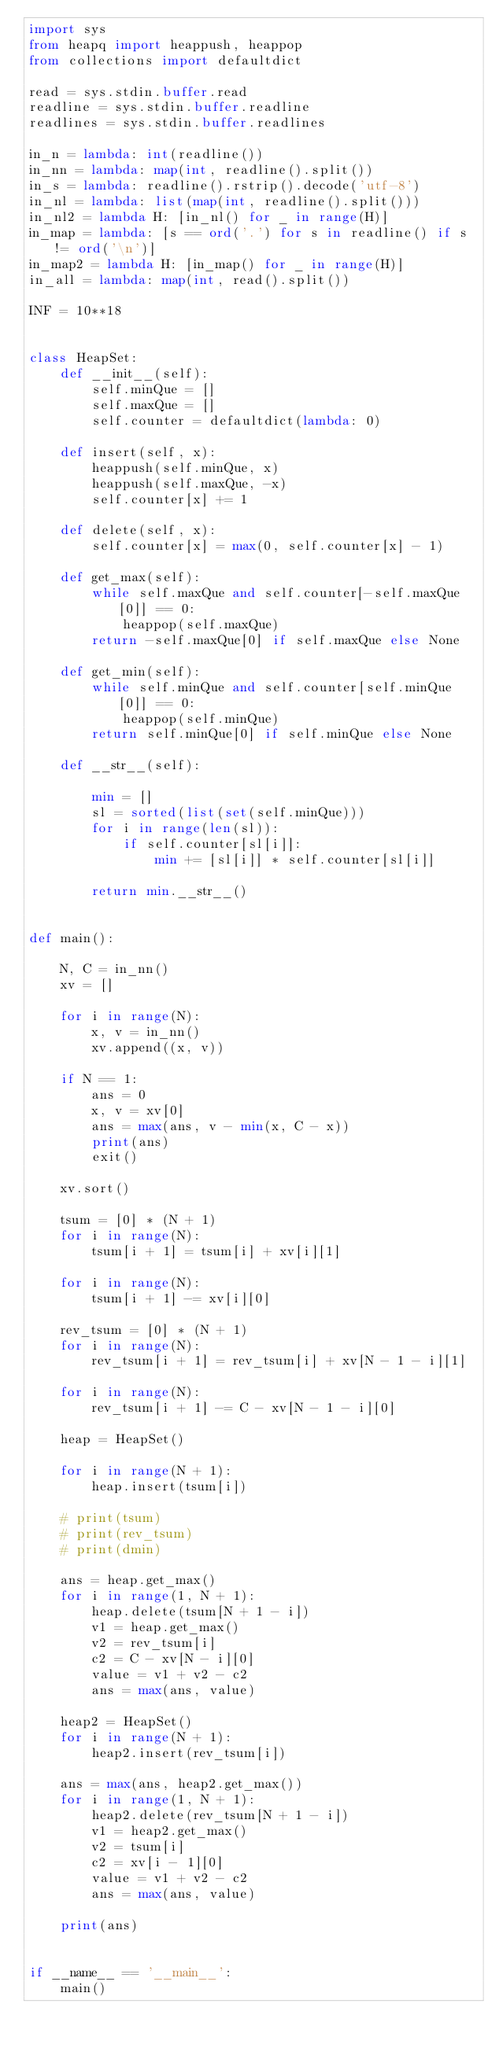<code> <loc_0><loc_0><loc_500><loc_500><_Python_>import sys
from heapq import heappush, heappop
from collections import defaultdict

read = sys.stdin.buffer.read
readline = sys.stdin.buffer.readline
readlines = sys.stdin.buffer.readlines

in_n = lambda: int(readline())
in_nn = lambda: map(int, readline().split())
in_s = lambda: readline().rstrip().decode('utf-8')
in_nl = lambda: list(map(int, readline().split()))
in_nl2 = lambda H: [in_nl() for _ in range(H)]
in_map = lambda: [s == ord('.') for s in readline() if s != ord('\n')]
in_map2 = lambda H: [in_map() for _ in range(H)]
in_all = lambda: map(int, read().split())

INF = 10**18


class HeapSet:
    def __init__(self):
        self.minQue = []
        self.maxQue = []
        self.counter = defaultdict(lambda: 0)

    def insert(self, x):
        heappush(self.minQue, x)
        heappush(self.maxQue, -x)
        self.counter[x] += 1

    def delete(self, x):
        self.counter[x] = max(0, self.counter[x] - 1)

    def get_max(self):
        while self.maxQue and self.counter[-self.maxQue[0]] == 0:
            heappop(self.maxQue)
        return -self.maxQue[0] if self.maxQue else None

    def get_min(self):
        while self.minQue and self.counter[self.minQue[0]] == 0:
            heappop(self.minQue)
        return self.minQue[0] if self.minQue else None

    def __str__(self):

        min = []
        sl = sorted(list(set(self.minQue)))
        for i in range(len(sl)):
            if self.counter[sl[i]]:
                min += [sl[i]] * self.counter[sl[i]]

        return min.__str__()


def main():

    N, C = in_nn()
    xv = []

    for i in range(N):
        x, v = in_nn()
        xv.append((x, v))

    if N == 1:
        ans = 0
        x, v = xv[0]
        ans = max(ans, v - min(x, C - x))
        print(ans)
        exit()

    xv.sort()

    tsum = [0] * (N + 1)
    for i in range(N):
        tsum[i + 1] = tsum[i] + xv[i][1]

    for i in range(N):
        tsum[i + 1] -= xv[i][0]

    rev_tsum = [0] * (N + 1)
    for i in range(N):
        rev_tsum[i + 1] = rev_tsum[i] + xv[N - 1 - i][1]

    for i in range(N):
        rev_tsum[i + 1] -= C - xv[N - 1 - i][0]

    heap = HeapSet()

    for i in range(N + 1):
        heap.insert(tsum[i])

    # print(tsum)
    # print(rev_tsum)
    # print(dmin)

    ans = heap.get_max()
    for i in range(1, N + 1):
        heap.delete(tsum[N + 1 - i])
        v1 = heap.get_max()
        v2 = rev_tsum[i]
        c2 = C - xv[N - i][0]
        value = v1 + v2 - c2
        ans = max(ans, value)

    heap2 = HeapSet()
    for i in range(N + 1):
        heap2.insert(rev_tsum[i])

    ans = max(ans, heap2.get_max())
    for i in range(1, N + 1):
        heap2.delete(rev_tsum[N + 1 - i])
        v1 = heap2.get_max()
        v2 = tsum[i]
        c2 = xv[i - 1][0]
        value = v1 + v2 - c2
        ans = max(ans, value)

    print(ans)


if __name__ == '__main__':
    main()
</code> 